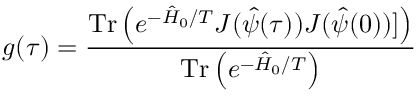Convert formula to latex. <formula><loc_0><loc_0><loc_500><loc_500>g ( \tau ) = \frac { T r \left ( e ^ { - \hat { H } _ { 0 } / T } J ( \hat { \psi } ( \tau ) ) J ( \hat { \psi } ( 0 ) ) ] \right ) } { T r \left ( e ^ { - \hat { H } _ { 0 } / T } \right ) } \,</formula> 